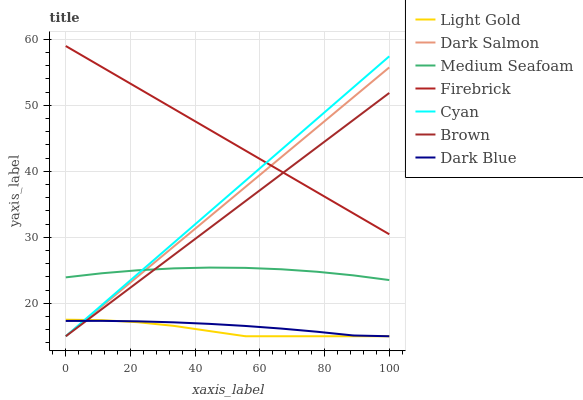Does Light Gold have the minimum area under the curve?
Answer yes or no. Yes. Does Firebrick have the maximum area under the curve?
Answer yes or no. Yes. Does Dark Salmon have the minimum area under the curve?
Answer yes or no. No. Does Dark Salmon have the maximum area under the curve?
Answer yes or no. No. Is Brown the smoothest?
Answer yes or no. Yes. Is Light Gold the roughest?
Answer yes or no. Yes. Is Firebrick the smoothest?
Answer yes or no. No. Is Firebrick the roughest?
Answer yes or no. No. Does Brown have the lowest value?
Answer yes or no. Yes. Does Firebrick have the lowest value?
Answer yes or no. No. Does Firebrick have the highest value?
Answer yes or no. Yes. Does Dark Salmon have the highest value?
Answer yes or no. No. Is Dark Blue less than Firebrick?
Answer yes or no. Yes. Is Firebrick greater than Light Gold?
Answer yes or no. Yes. Does Light Gold intersect Brown?
Answer yes or no. Yes. Is Light Gold less than Brown?
Answer yes or no. No. Is Light Gold greater than Brown?
Answer yes or no. No. Does Dark Blue intersect Firebrick?
Answer yes or no. No. 